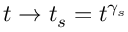Convert formula to latex. <formula><loc_0><loc_0><loc_500><loc_500>t \rightarrow t _ { s } = t ^ { \gamma _ { s } }</formula> 